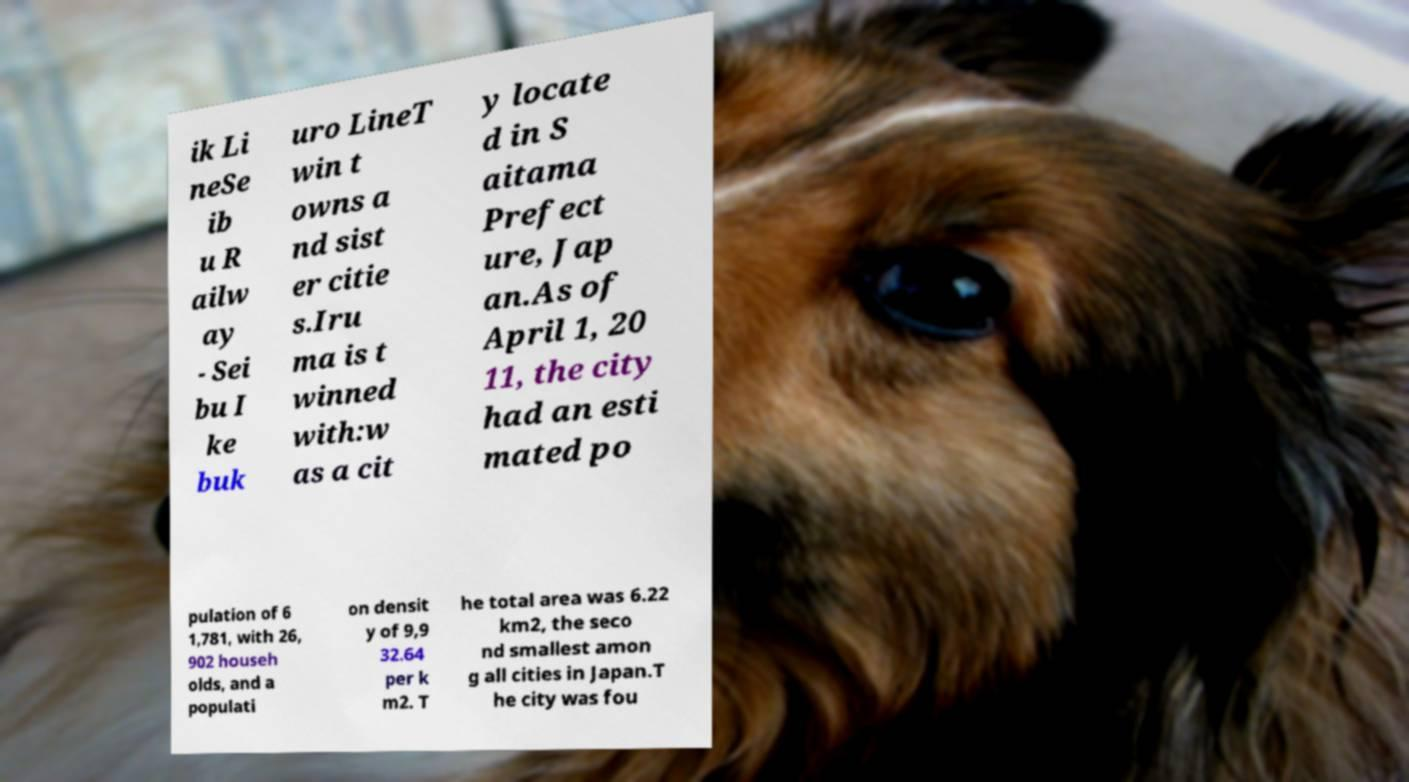What messages or text are displayed in this image? I need them in a readable, typed format. ik Li neSe ib u R ailw ay - Sei bu I ke buk uro LineT win t owns a nd sist er citie s.Iru ma is t winned with:w as a cit y locate d in S aitama Prefect ure, Jap an.As of April 1, 20 11, the city had an esti mated po pulation of 6 1,781, with 26, 902 househ olds, and a populati on densit y of 9,9 32.64 per k m2. T he total area was 6.22 km2, the seco nd smallest amon g all cities in Japan.T he city was fou 